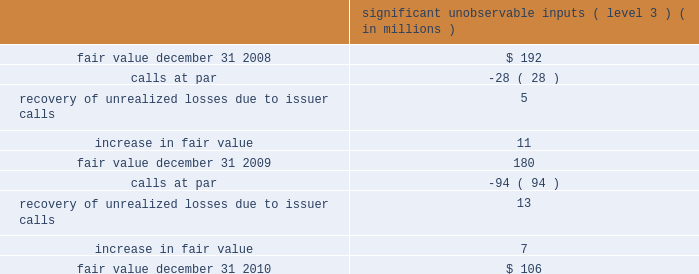Mastercard incorporated notes to consolidated financial statements 2014continued the municipal bond portfolio is comprised of tax exempt bonds and is diversified across states and sectors .
The portfolio has an average credit quality of double-a .
The short-term bond funds invest in fixed income securities , including corporate bonds , mortgage-backed securities and asset-backed securities .
The company holds investments in ars .
Interest on these securities is exempt from u.s .
Federal income tax and the interest rate on the securities typically resets every 35 days .
The securities are fully collateralized by student loans with guarantees , ranging from approximately 95% ( 95 % ) to 98% ( 98 % ) of principal and interest , by the u.s .
Government via the department of education .
Beginning on february 11 , 2008 , the auction mechanism that normally provided liquidity to the ars investments began to fail .
Since mid-february 2008 , all investment positions in the company 2019s ars investment portfolio have experienced failed auctions .
The securities for which auctions have failed have continued to pay interest in accordance with the contractual terms of such instruments and will continue to accrue interest and be auctioned at each respective reset date until the auction succeeds , the issuer redeems the securities or they mature .
During 2008 , ars were reclassified as level 3 from level 2 .
As of december 31 , 2010 , the ars market remained illiquid , but issuer call and redemption activity in the ars student loan sector has occurred periodically since the auctions began to fail .
During 2010 and 2009 , the company did not sell any ars in the auction market , but there were calls at par .
The table below includes a roll-forward of the company 2019s ars investments from january 1 , 2009 to december 31 , 2010 .
Significant unobservable inputs ( level 3 ) ( in millions ) .
The company evaluated the estimated impairment of its ars portfolio to determine if it was other-than- temporary .
The company considered several factors including , but not limited to , the following : ( 1 ) the reasons for the decline in value ( changes in interest rates , credit event , or market fluctuations ) ; ( 2 ) assessments as to whether it is more likely than not that it will hold and not be required to sell the investments for a sufficient period of time to allow for recovery of the cost basis ; ( 3 ) whether the decline is substantial ; and ( 4 ) the historical and anticipated duration of the events causing the decline in value .
The evaluation for other-than-temporary impairments is a quantitative and qualitative process , which is subject to various risks and uncertainties .
The risks and uncertainties include changes in credit quality , market liquidity , timing and amounts of issuer calls and interest rates .
As of december 31 , 2010 , the company believed that the unrealized losses on the ars were not related to credit quality but rather due to the lack of liquidity in the market .
The company believes that it is more .
What is the percentual decrease observed in the fair value of ars investments between 2009 and 2008? 
Rationale: it is the percentual decrease observed in the fair value of ars investments , which is calculated by subtracting the 2009's value of 2008 one , then dividing by the 2008 and turning it into a percentage .
Computations: ((180 - 192) / 192)
Answer: -0.0625. 